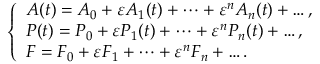<formula> <loc_0><loc_0><loc_500><loc_500>\begin{array} { r } { \left \{ \begin{array} { l l } { A ( t ) = A _ { 0 } + \varepsilon A _ { 1 } ( t ) + \dots + \varepsilon ^ { n } A _ { n } ( t ) + \dots , } \\ { P ( t ) = P _ { 0 } + \varepsilon P _ { 1 } ( t ) + \dots + \varepsilon ^ { n } P _ { n } ( t ) + \dots , } \\ { F = F _ { 0 } + \varepsilon F _ { 1 } + \dots + \varepsilon ^ { n } F _ { n } + \dots . } \end{array} } \end{array}</formula> 